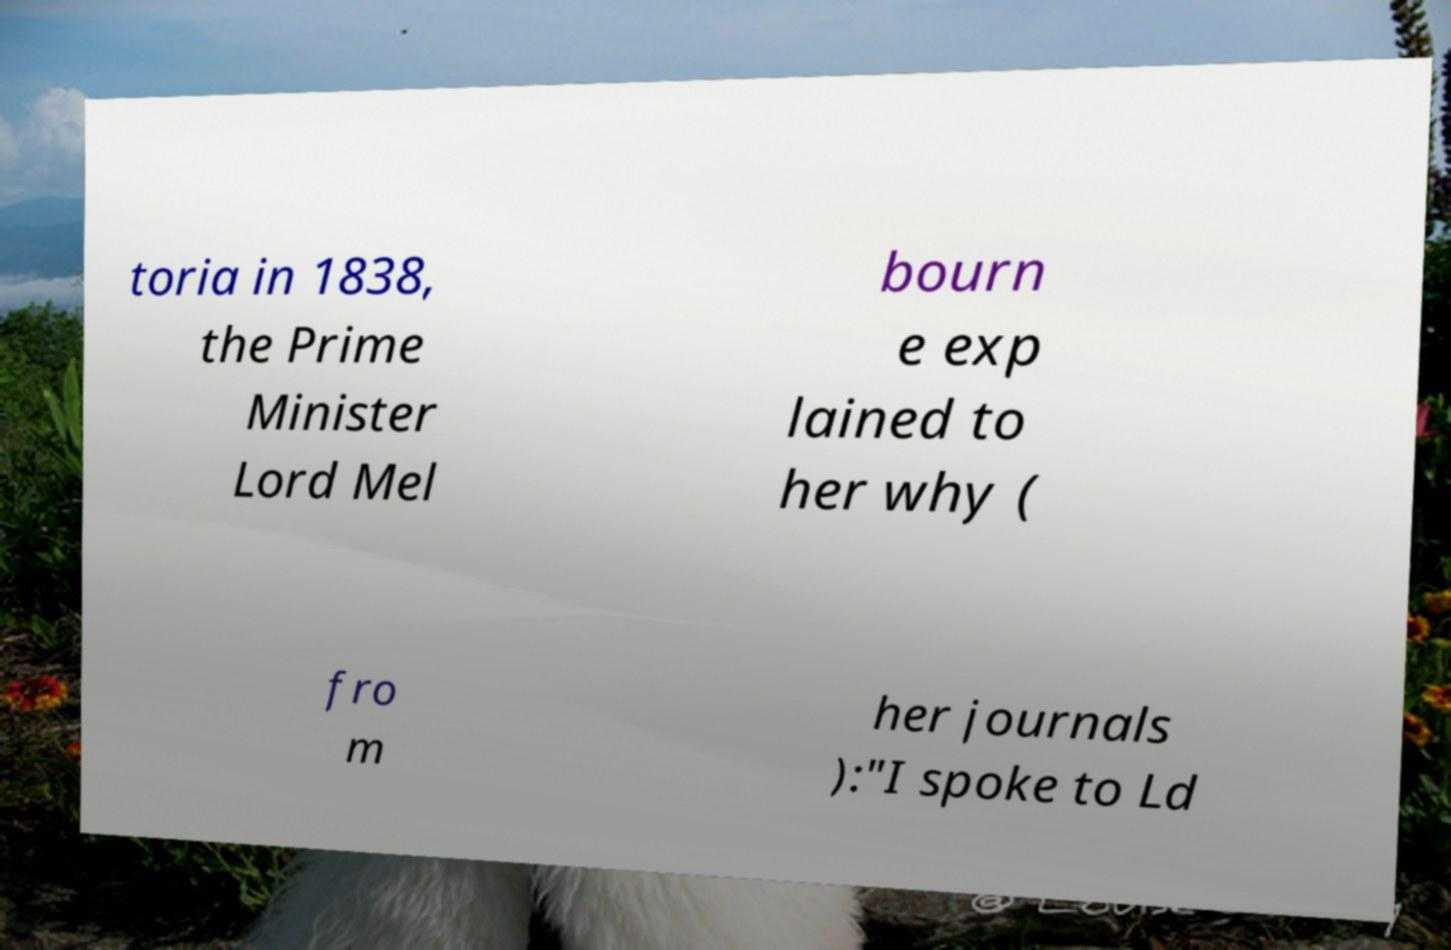Could you assist in decoding the text presented in this image and type it out clearly? toria in 1838, the Prime Minister Lord Mel bourn e exp lained to her why ( fro m her journals ):"I spoke to Ld 